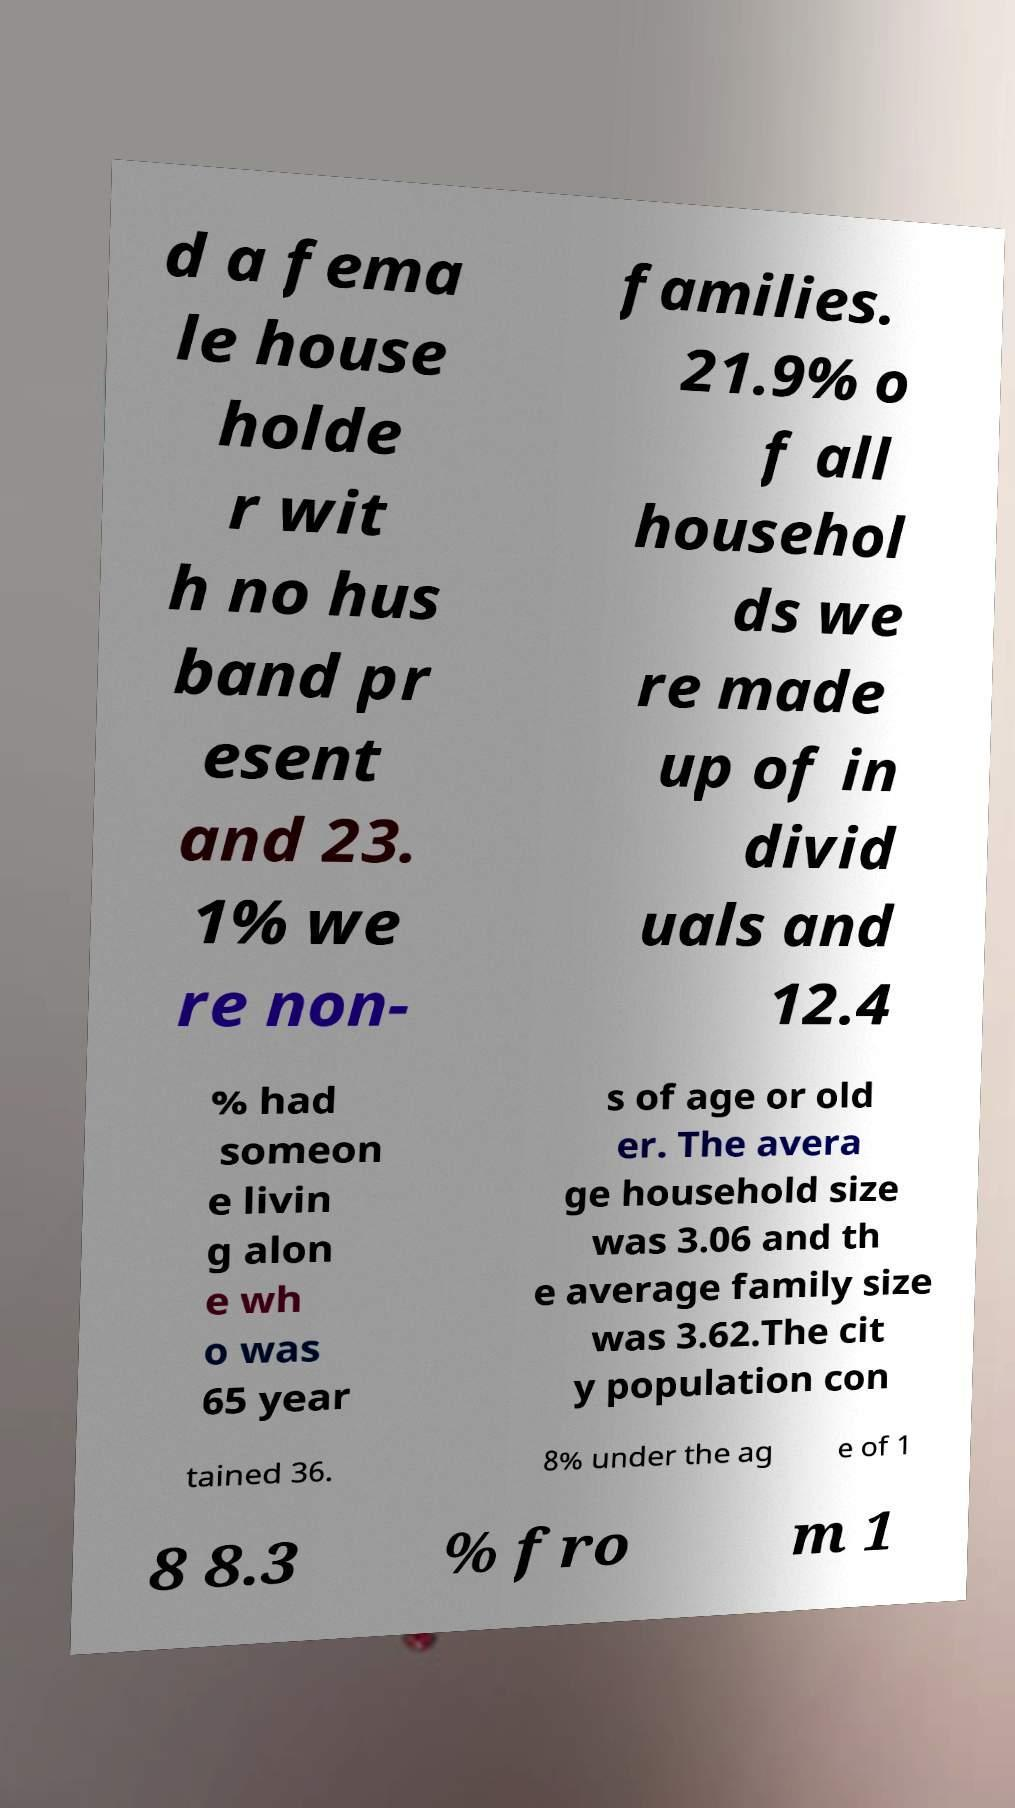For documentation purposes, I need the text within this image transcribed. Could you provide that? d a fema le house holde r wit h no hus band pr esent and 23. 1% we re non- families. 21.9% o f all househol ds we re made up of in divid uals and 12.4 % had someon e livin g alon e wh o was 65 year s of age or old er. The avera ge household size was 3.06 and th e average family size was 3.62.The cit y population con tained 36. 8% under the ag e of 1 8 8.3 % fro m 1 